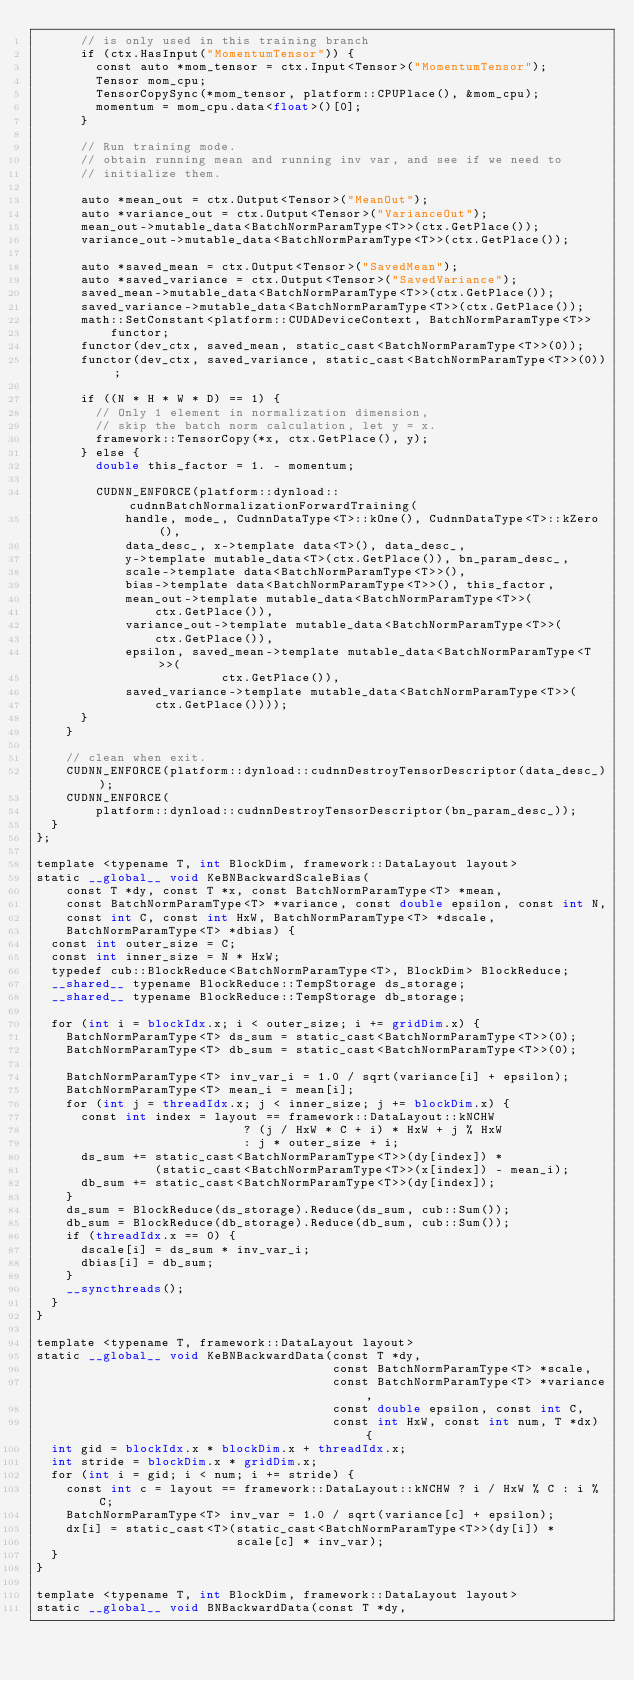<code> <loc_0><loc_0><loc_500><loc_500><_Cuda_>      // is only used in this training branch
      if (ctx.HasInput("MomentumTensor")) {
        const auto *mom_tensor = ctx.Input<Tensor>("MomentumTensor");
        Tensor mom_cpu;
        TensorCopySync(*mom_tensor, platform::CPUPlace(), &mom_cpu);
        momentum = mom_cpu.data<float>()[0];
      }

      // Run training mode.
      // obtain running mean and running inv var, and see if we need to
      // initialize them.

      auto *mean_out = ctx.Output<Tensor>("MeanOut");
      auto *variance_out = ctx.Output<Tensor>("VarianceOut");
      mean_out->mutable_data<BatchNormParamType<T>>(ctx.GetPlace());
      variance_out->mutable_data<BatchNormParamType<T>>(ctx.GetPlace());

      auto *saved_mean = ctx.Output<Tensor>("SavedMean");
      auto *saved_variance = ctx.Output<Tensor>("SavedVariance");
      saved_mean->mutable_data<BatchNormParamType<T>>(ctx.GetPlace());
      saved_variance->mutable_data<BatchNormParamType<T>>(ctx.GetPlace());
      math::SetConstant<platform::CUDADeviceContext, BatchNormParamType<T>>
          functor;
      functor(dev_ctx, saved_mean, static_cast<BatchNormParamType<T>>(0));
      functor(dev_ctx, saved_variance, static_cast<BatchNormParamType<T>>(0));

      if ((N * H * W * D) == 1) {
        // Only 1 element in normalization dimension,
        // skip the batch norm calculation, let y = x.
        framework::TensorCopy(*x, ctx.GetPlace(), y);
      } else {
        double this_factor = 1. - momentum;

        CUDNN_ENFORCE(platform::dynload::cudnnBatchNormalizationForwardTraining(
            handle, mode_, CudnnDataType<T>::kOne(), CudnnDataType<T>::kZero(),
            data_desc_, x->template data<T>(), data_desc_,
            y->template mutable_data<T>(ctx.GetPlace()), bn_param_desc_,
            scale->template data<BatchNormParamType<T>>(),
            bias->template data<BatchNormParamType<T>>(), this_factor,
            mean_out->template mutable_data<BatchNormParamType<T>>(
                ctx.GetPlace()),
            variance_out->template mutable_data<BatchNormParamType<T>>(
                ctx.GetPlace()),
            epsilon, saved_mean->template mutable_data<BatchNormParamType<T>>(
                         ctx.GetPlace()),
            saved_variance->template mutable_data<BatchNormParamType<T>>(
                ctx.GetPlace())));
      }
    }

    // clean when exit.
    CUDNN_ENFORCE(platform::dynload::cudnnDestroyTensorDescriptor(data_desc_));
    CUDNN_ENFORCE(
        platform::dynload::cudnnDestroyTensorDescriptor(bn_param_desc_));
  }
};

template <typename T, int BlockDim, framework::DataLayout layout>
static __global__ void KeBNBackwardScaleBias(
    const T *dy, const T *x, const BatchNormParamType<T> *mean,
    const BatchNormParamType<T> *variance, const double epsilon, const int N,
    const int C, const int HxW, BatchNormParamType<T> *dscale,
    BatchNormParamType<T> *dbias) {
  const int outer_size = C;
  const int inner_size = N * HxW;
  typedef cub::BlockReduce<BatchNormParamType<T>, BlockDim> BlockReduce;
  __shared__ typename BlockReduce::TempStorage ds_storage;
  __shared__ typename BlockReduce::TempStorage db_storage;

  for (int i = blockIdx.x; i < outer_size; i += gridDim.x) {
    BatchNormParamType<T> ds_sum = static_cast<BatchNormParamType<T>>(0);
    BatchNormParamType<T> db_sum = static_cast<BatchNormParamType<T>>(0);

    BatchNormParamType<T> inv_var_i = 1.0 / sqrt(variance[i] + epsilon);
    BatchNormParamType<T> mean_i = mean[i];
    for (int j = threadIdx.x; j < inner_size; j += blockDim.x) {
      const int index = layout == framework::DataLayout::kNCHW
                            ? (j / HxW * C + i) * HxW + j % HxW
                            : j * outer_size + i;
      ds_sum += static_cast<BatchNormParamType<T>>(dy[index]) *
                (static_cast<BatchNormParamType<T>>(x[index]) - mean_i);
      db_sum += static_cast<BatchNormParamType<T>>(dy[index]);
    }
    ds_sum = BlockReduce(ds_storage).Reduce(ds_sum, cub::Sum());
    db_sum = BlockReduce(db_storage).Reduce(db_sum, cub::Sum());
    if (threadIdx.x == 0) {
      dscale[i] = ds_sum * inv_var_i;
      dbias[i] = db_sum;
    }
    __syncthreads();
  }
}

template <typename T, framework::DataLayout layout>
static __global__ void KeBNBackwardData(const T *dy,
                                        const BatchNormParamType<T> *scale,
                                        const BatchNormParamType<T> *variance,
                                        const double epsilon, const int C,
                                        const int HxW, const int num, T *dx) {
  int gid = blockIdx.x * blockDim.x + threadIdx.x;
  int stride = blockDim.x * gridDim.x;
  for (int i = gid; i < num; i += stride) {
    const int c = layout == framework::DataLayout::kNCHW ? i / HxW % C : i % C;
    BatchNormParamType<T> inv_var = 1.0 / sqrt(variance[c] + epsilon);
    dx[i] = static_cast<T>(static_cast<BatchNormParamType<T>>(dy[i]) *
                           scale[c] * inv_var);
  }
}

template <typename T, int BlockDim, framework::DataLayout layout>
static __global__ void BNBackwardData(const T *dy,</code> 